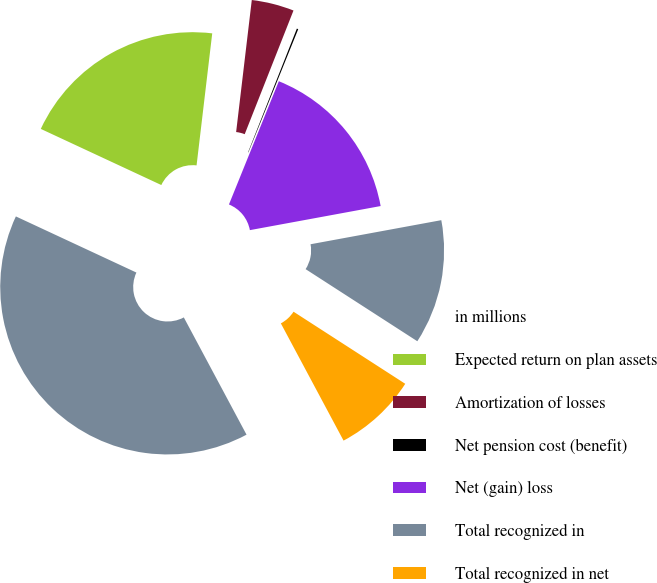Convert chart to OTSL. <chart><loc_0><loc_0><loc_500><loc_500><pie_chart><fcel>in millions<fcel>Expected return on plan assets<fcel>Amortization of losses<fcel>Net pension cost (benefit)<fcel>Net (gain) loss<fcel>Total recognized in<fcel>Total recognized in net<nl><fcel>39.75%<fcel>19.94%<fcel>4.1%<fcel>0.14%<fcel>15.98%<fcel>12.02%<fcel>8.06%<nl></chart> 